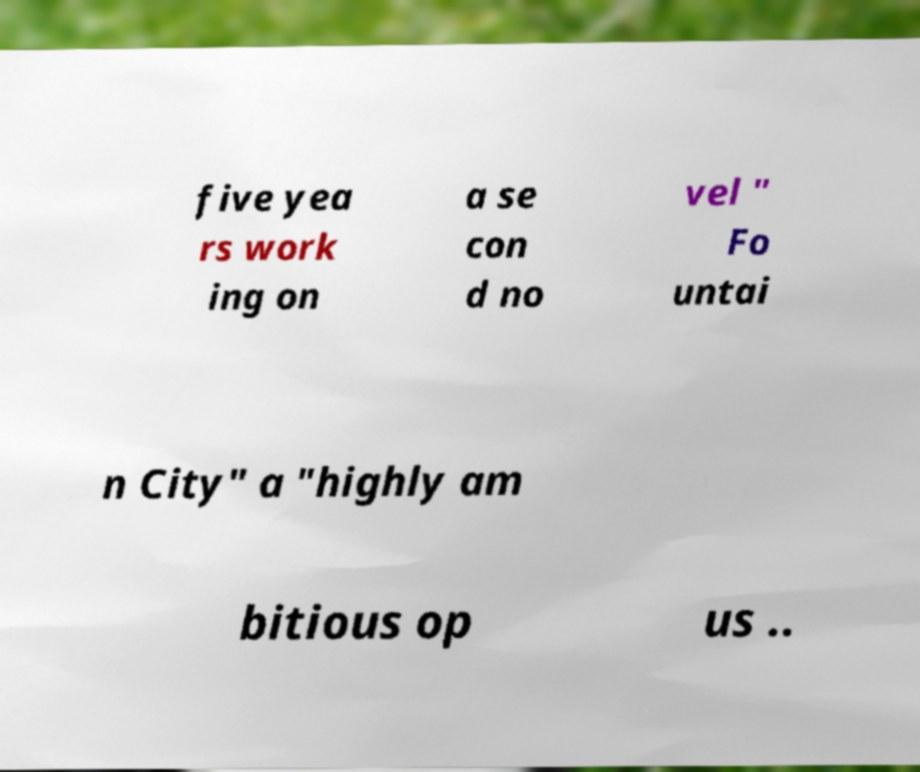Please identify and transcribe the text found in this image. five yea rs work ing on a se con d no vel " Fo untai n City" a "highly am bitious op us .. 